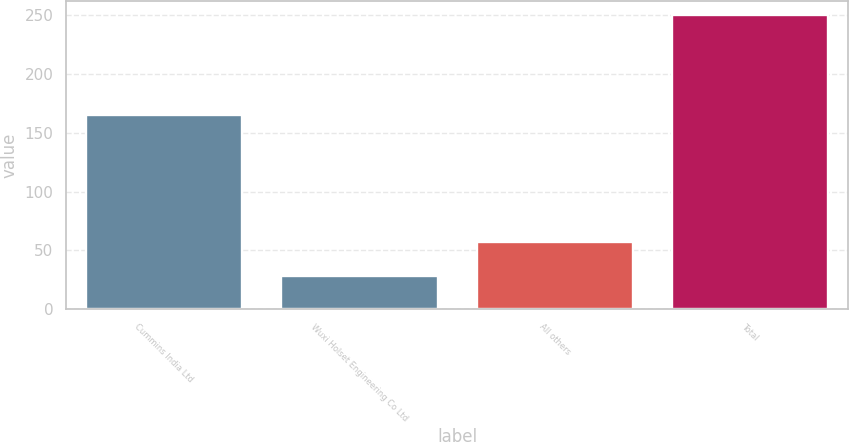<chart> <loc_0><loc_0><loc_500><loc_500><bar_chart><fcel>Cummins India Ltd<fcel>Wuxi Holset Engineering Co Ltd<fcel>All others<fcel>Total<nl><fcel>165<fcel>28<fcel>57<fcel>250<nl></chart> 